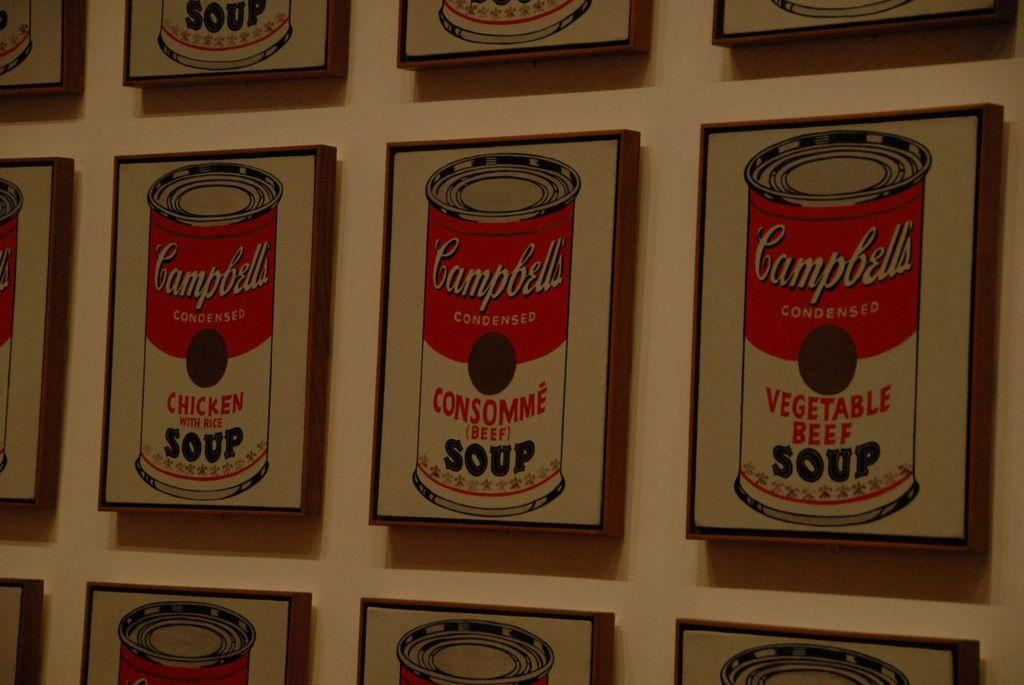<image>
Write a terse but informative summary of the picture. Many paintings of Campbell's soup hang on a wall. 